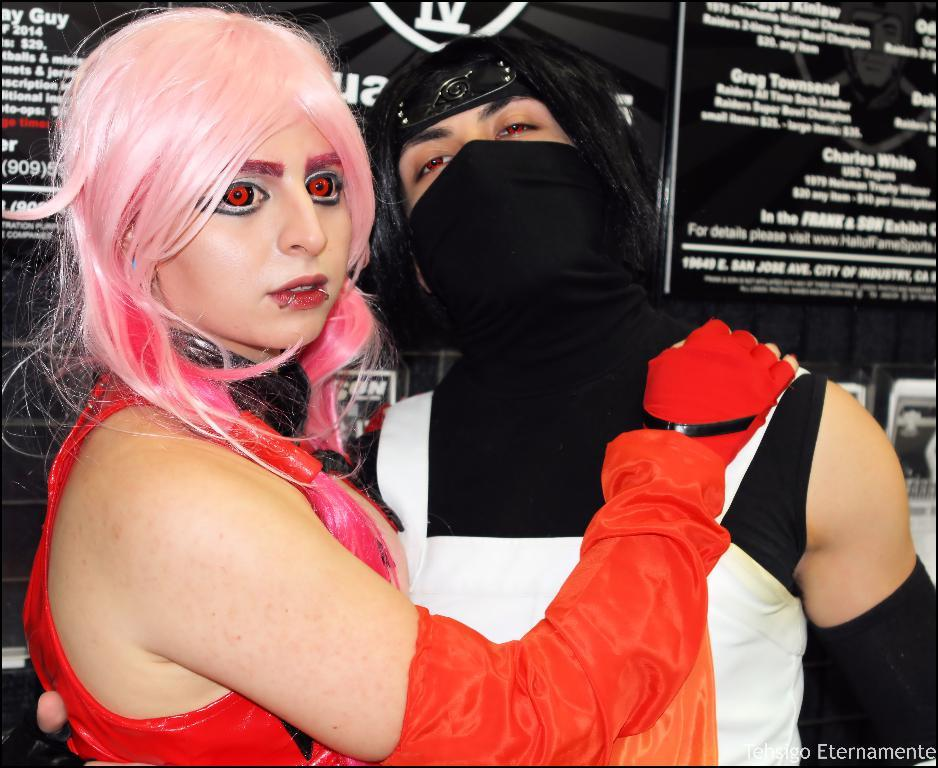Provide a one-sentence caption for the provided image. A girl with scary red eyes stands in front of a black sign with Charles White and Gregeg Townsend listed. 